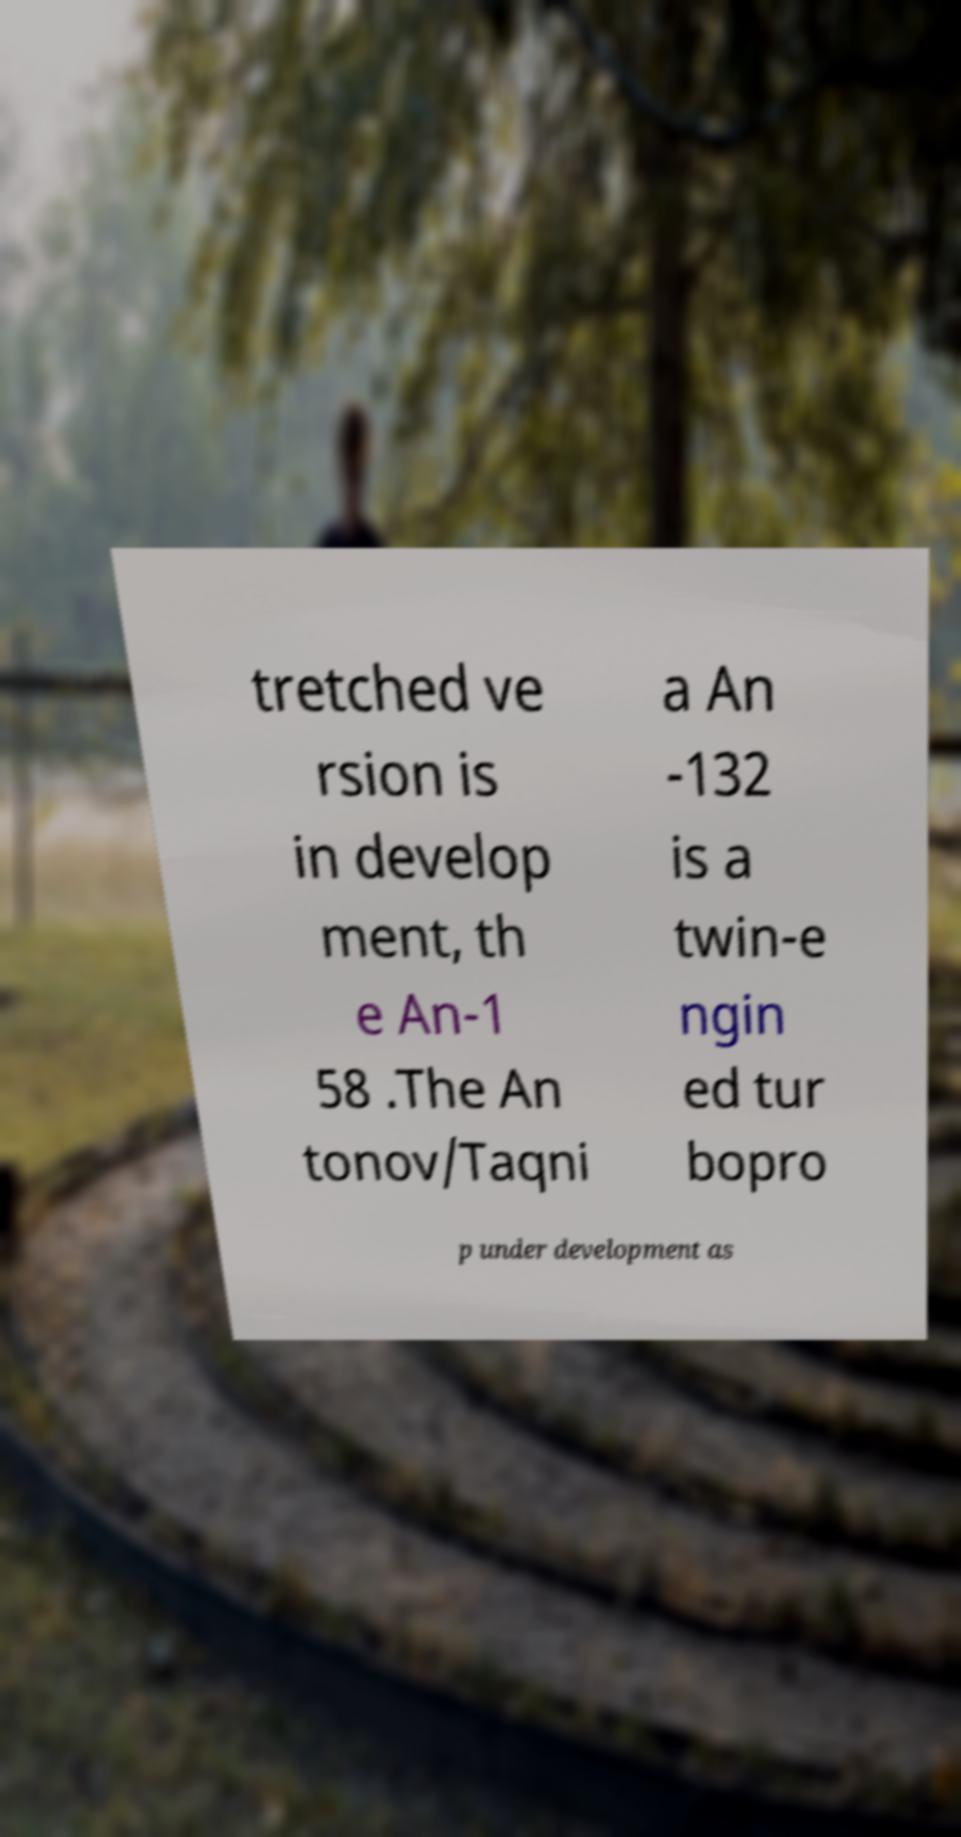What messages or text are displayed in this image? I need them in a readable, typed format. tretched ve rsion is in develop ment, th e An-1 58 .The An tonov/Taqni a An -132 is a twin-e ngin ed tur bopro p under development as 